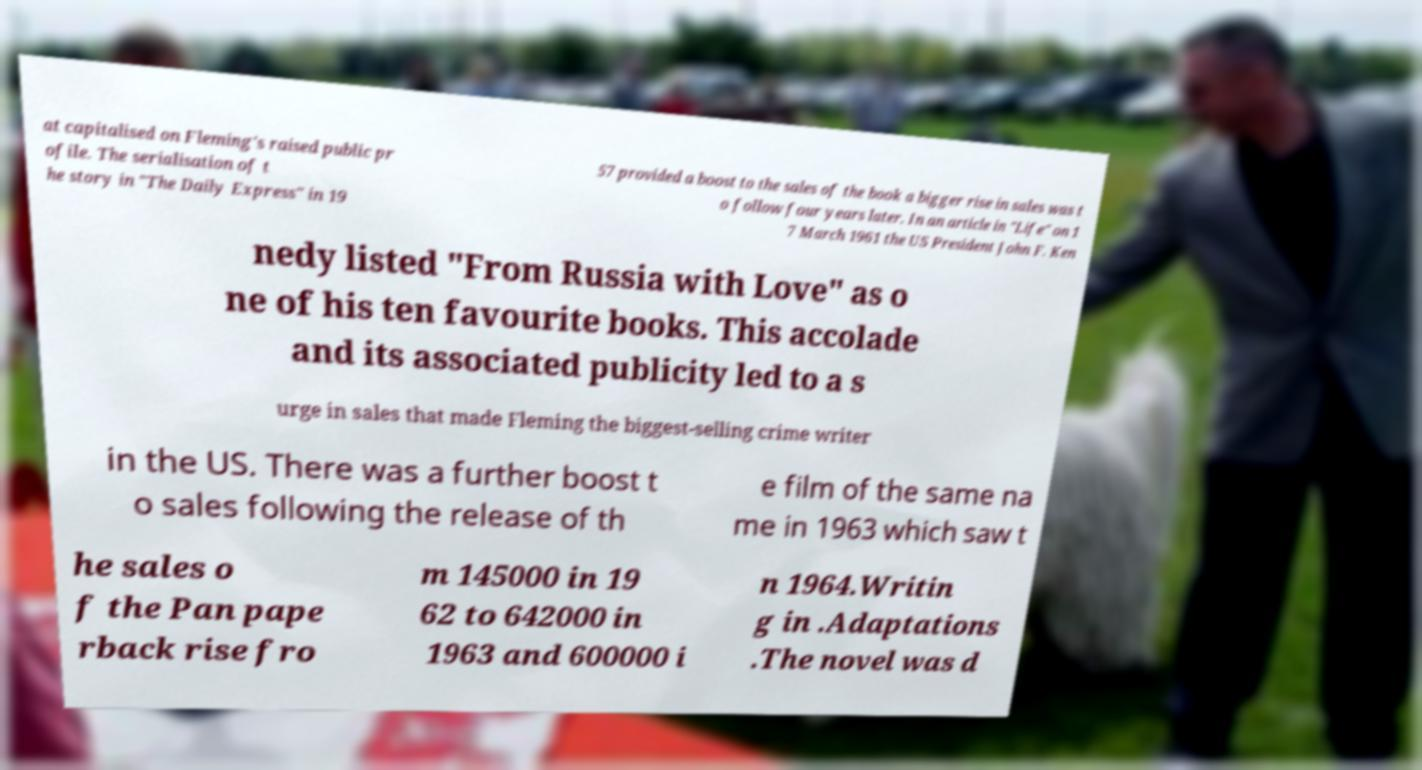There's text embedded in this image that I need extracted. Can you transcribe it verbatim? at capitalised on Fleming's raised public pr ofile. The serialisation of t he story in "The Daily Express" in 19 57 provided a boost to the sales of the book a bigger rise in sales was t o follow four years later. In an article in "Life" on 1 7 March 1961 the US President John F. Ken nedy listed "From Russia with Love" as o ne of his ten favourite books. This accolade and its associated publicity led to a s urge in sales that made Fleming the biggest-selling crime writer in the US. There was a further boost t o sales following the release of th e film of the same na me in 1963 which saw t he sales o f the Pan pape rback rise fro m 145000 in 19 62 to 642000 in 1963 and 600000 i n 1964.Writin g in .Adaptations .The novel was d 